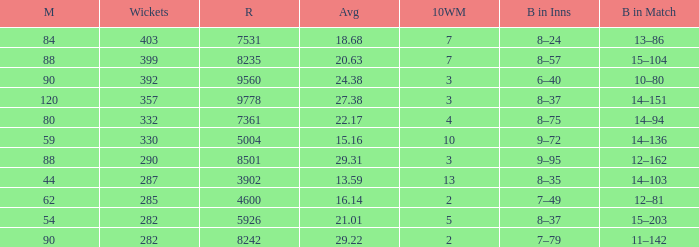What is the total number of wickets that have runs under 4600 and matches under 44? None. 